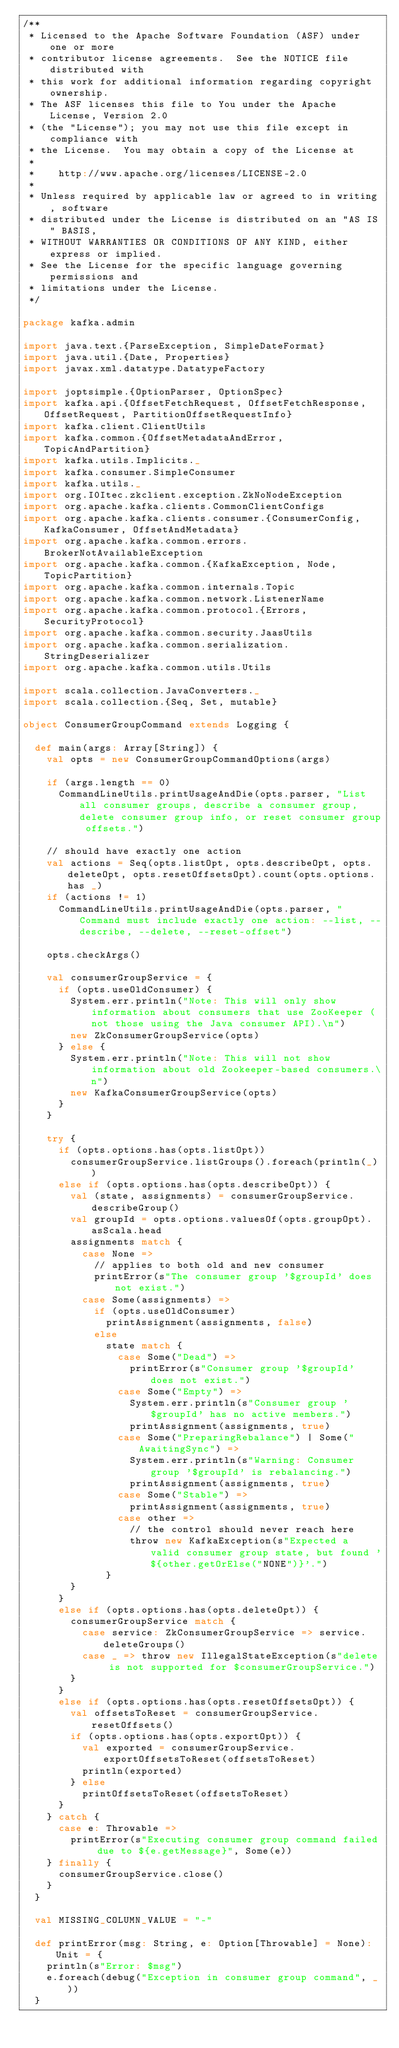Convert code to text. <code><loc_0><loc_0><loc_500><loc_500><_Scala_>/**
 * Licensed to the Apache Software Foundation (ASF) under one or more
 * contributor license agreements.  See the NOTICE file distributed with
 * this work for additional information regarding copyright ownership.
 * The ASF licenses this file to You under the Apache License, Version 2.0
 * (the "License"); you may not use this file except in compliance with
 * the License.  You may obtain a copy of the License at
 *
 *    http://www.apache.org/licenses/LICENSE-2.0
 *
 * Unless required by applicable law or agreed to in writing, software
 * distributed under the License is distributed on an "AS IS" BASIS,
 * WITHOUT WARRANTIES OR CONDITIONS OF ANY KIND, either express or implied.
 * See the License for the specific language governing permissions and
 * limitations under the License.
 */

package kafka.admin

import java.text.{ParseException, SimpleDateFormat}
import java.util.{Date, Properties}
import javax.xml.datatype.DatatypeFactory

import joptsimple.{OptionParser, OptionSpec}
import kafka.api.{OffsetFetchRequest, OffsetFetchResponse, OffsetRequest, PartitionOffsetRequestInfo}
import kafka.client.ClientUtils
import kafka.common.{OffsetMetadataAndError, TopicAndPartition}
import kafka.utils.Implicits._
import kafka.consumer.SimpleConsumer
import kafka.utils._
import org.I0Itec.zkclient.exception.ZkNoNodeException
import org.apache.kafka.clients.CommonClientConfigs
import org.apache.kafka.clients.consumer.{ConsumerConfig, KafkaConsumer, OffsetAndMetadata}
import org.apache.kafka.common.errors.BrokerNotAvailableException
import org.apache.kafka.common.{KafkaException, Node, TopicPartition}
import org.apache.kafka.common.internals.Topic
import org.apache.kafka.common.network.ListenerName
import org.apache.kafka.common.protocol.{Errors, SecurityProtocol}
import org.apache.kafka.common.security.JaasUtils
import org.apache.kafka.common.serialization.StringDeserializer
import org.apache.kafka.common.utils.Utils

import scala.collection.JavaConverters._
import scala.collection.{Seq, Set, mutable}

object ConsumerGroupCommand extends Logging {

  def main(args: Array[String]) {
    val opts = new ConsumerGroupCommandOptions(args)

    if (args.length == 0)
      CommandLineUtils.printUsageAndDie(opts.parser, "List all consumer groups, describe a consumer group, delete consumer group info, or reset consumer group offsets.")

    // should have exactly one action
    val actions = Seq(opts.listOpt, opts.describeOpt, opts.deleteOpt, opts.resetOffsetsOpt).count(opts.options.has _)
    if (actions != 1)
      CommandLineUtils.printUsageAndDie(opts.parser, "Command must include exactly one action: --list, --describe, --delete, --reset-offset")

    opts.checkArgs()

    val consumerGroupService = {
      if (opts.useOldConsumer) {
        System.err.println("Note: This will only show information about consumers that use ZooKeeper (not those using the Java consumer API).\n")
        new ZkConsumerGroupService(opts)
      } else {
        System.err.println("Note: This will not show information about old Zookeeper-based consumers.\n")
        new KafkaConsumerGroupService(opts)
      }
    }

    try {
      if (opts.options.has(opts.listOpt))
        consumerGroupService.listGroups().foreach(println(_))
      else if (opts.options.has(opts.describeOpt)) {
        val (state, assignments) = consumerGroupService.describeGroup()
        val groupId = opts.options.valuesOf(opts.groupOpt).asScala.head
        assignments match {
          case None =>
            // applies to both old and new consumer
            printError(s"The consumer group '$groupId' does not exist.")
          case Some(assignments) =>
            if (opts.useOldConsumer)
              printAssignment(assignments, false)
            else
              state match {
                case Some("Dead") =>
                  printError(s"Consumer group '$groupId' does not exist.")
                case Some("Empty") =>
                  System.err.println(s"Consumer group '$groupId' has no active members.")
                  printAssignment(assignments, true)
                case Some("PreparingRebalance") | Some("AwaitingSync") =>
                  System.err.println(s"Warning: Consumer group '$groupId' is rebalancing.")
                  printAssignment(assignments, true)
                case Some("Stable") =>
                  printAssignment(assignments, true)
                case other =>
                  // the control should never reach here
                  throw new KafkaException(s"Expected a valid consumer group state, but found '${other.getOrElse("NONE")}'.")
              }
        }
      }
      else if (opts.options.has(opts.deleteOpt)) {
        consumerGroupService match {
          case service: ZkConsumerGroupService => service.deleteGroups()
          case _ => throw new IllegalStateException(s"delete is not supported for $consumerGroupService.")
        }
      }
      else if (opts.options.has(opts.resetOffsetsOpt)) {
        val offsetsToReset = consumerGroupService.resetOffsets()
        if (opts.options.has(opts.exportOpt)) {
          val exported = consumerGroupService.exportOffsetsToReset(offsetsToReset)
          println(exported)
        } else
          printOffsetsToReset(offsetsToReset)
      }
    } catch {
      case e: Throwable =>
        printError(s"Executing consumer group command failed due to ${e.getMessage}", Some(e))
    } finally {
      consumerGroupService.close()
    }
  }

  val MISSING_COLUMN_VALUE = "-"

  def printError(msg: String, e: Option[Throwable] = None): Unit = {
    println(s"Error: $msg")
    e.foreach(debug("Exception in consumer group command", _))
  }
</code> 